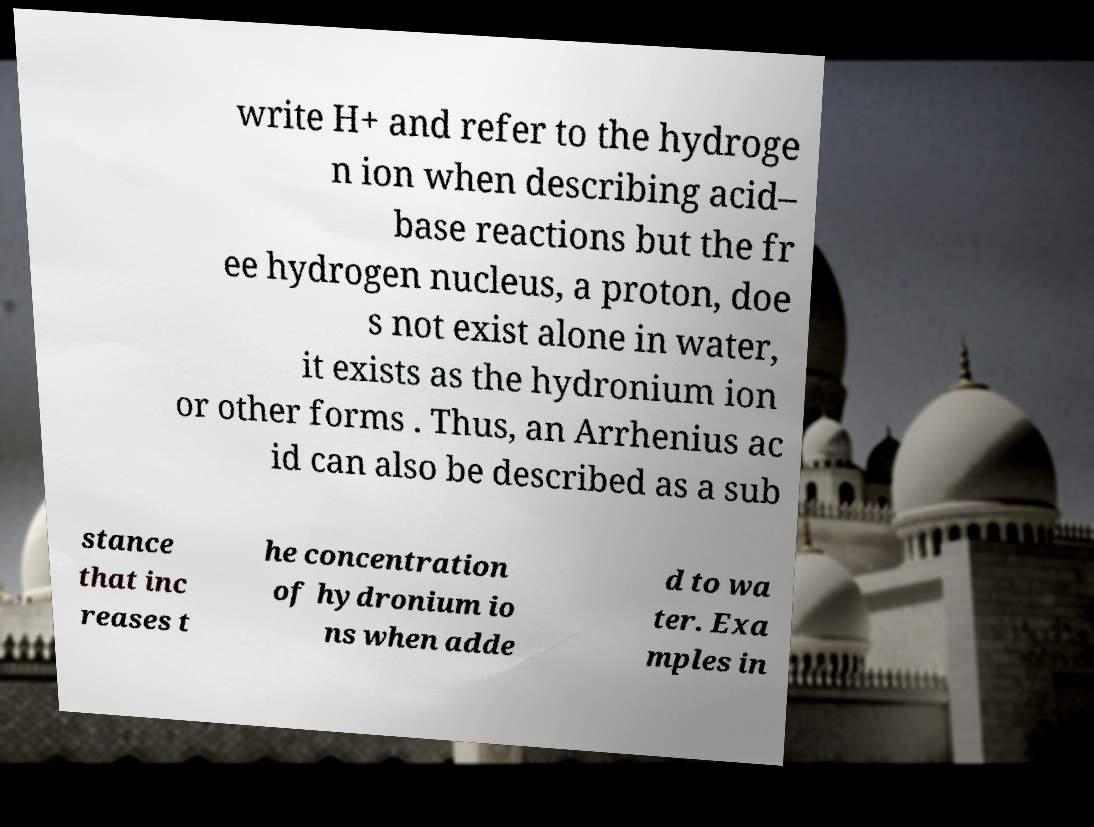Can you accurately transcribe the text from the provided image for me? write H+ and refer to the hydroge n ion when describing acid– base reactions but the fr ee hydrogen nucleus, a proton, doe s not exist alone in water, it exists as the hydronium ion or other forms . Thus, an Arrhenius ac id can also be described as a sub stance that inc reases t he concentration of hydronium io ns when adde d to wa ter. Exa mples in 